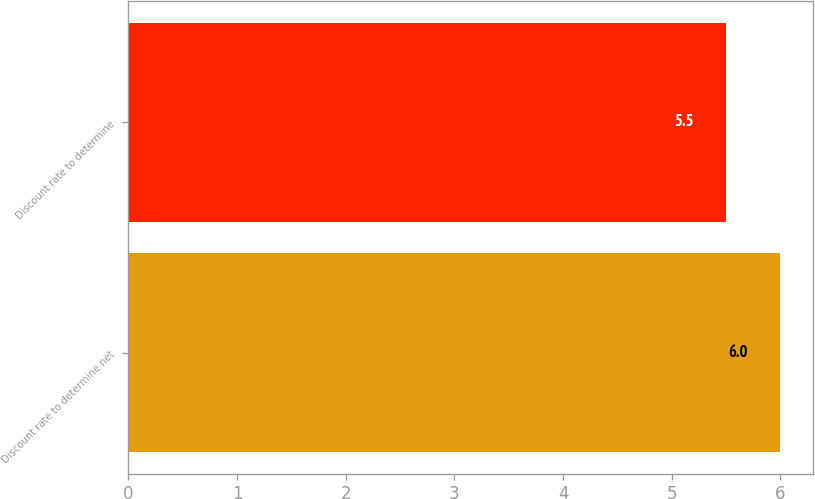Convert chart. <chart><loc_0><loc_0><loc_500><loc_500><bar_chart><fcel>Discount rate to determine net<fcel>Discount rate to determine<nl><fcel>6<fcel>5.5<nl></chart> 